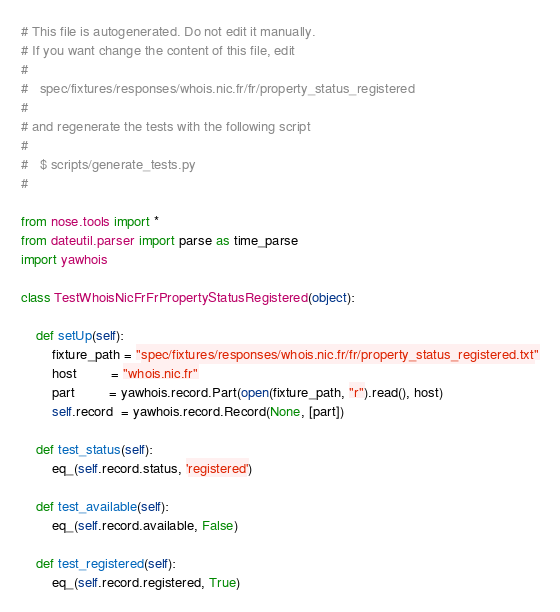<code> <loc_0><loc_0><loc_500><loc_500><_Python_>
# This file is autogenerated. Do not edit it manually.
# If you want change the content of this file, edit
#
#   spec/fixtures/responses/whois.nic.fr/fr/property_status_registered
#
# and regenerate the tests with the following script
#
#   $ scripts/generate_tests.py
#

from nose.tools import *
from dateutil.parser import parse as time_parse
import yawhois

class TestWhoisNicFrFrPropertyStatusRegistered(object):

    def setUp(self):
        fixture_path = "spec/fixtures/responses/whois.nic.fr/fr/property_status_registered.txt"
        host         = "whois.nic.fr"
        part         = yawhois.record.Part(open(fixture_path, "r").read(), host)
        self.record  = yawhois.record.Record(None, [part])

    def test_status(self):
        eq_(self.record.status, 'registered')

    def test_available(self):
        eq_(self.record.available, False)

    def test_registered(self):
        eq_(self.record.registered, True)
</code> 